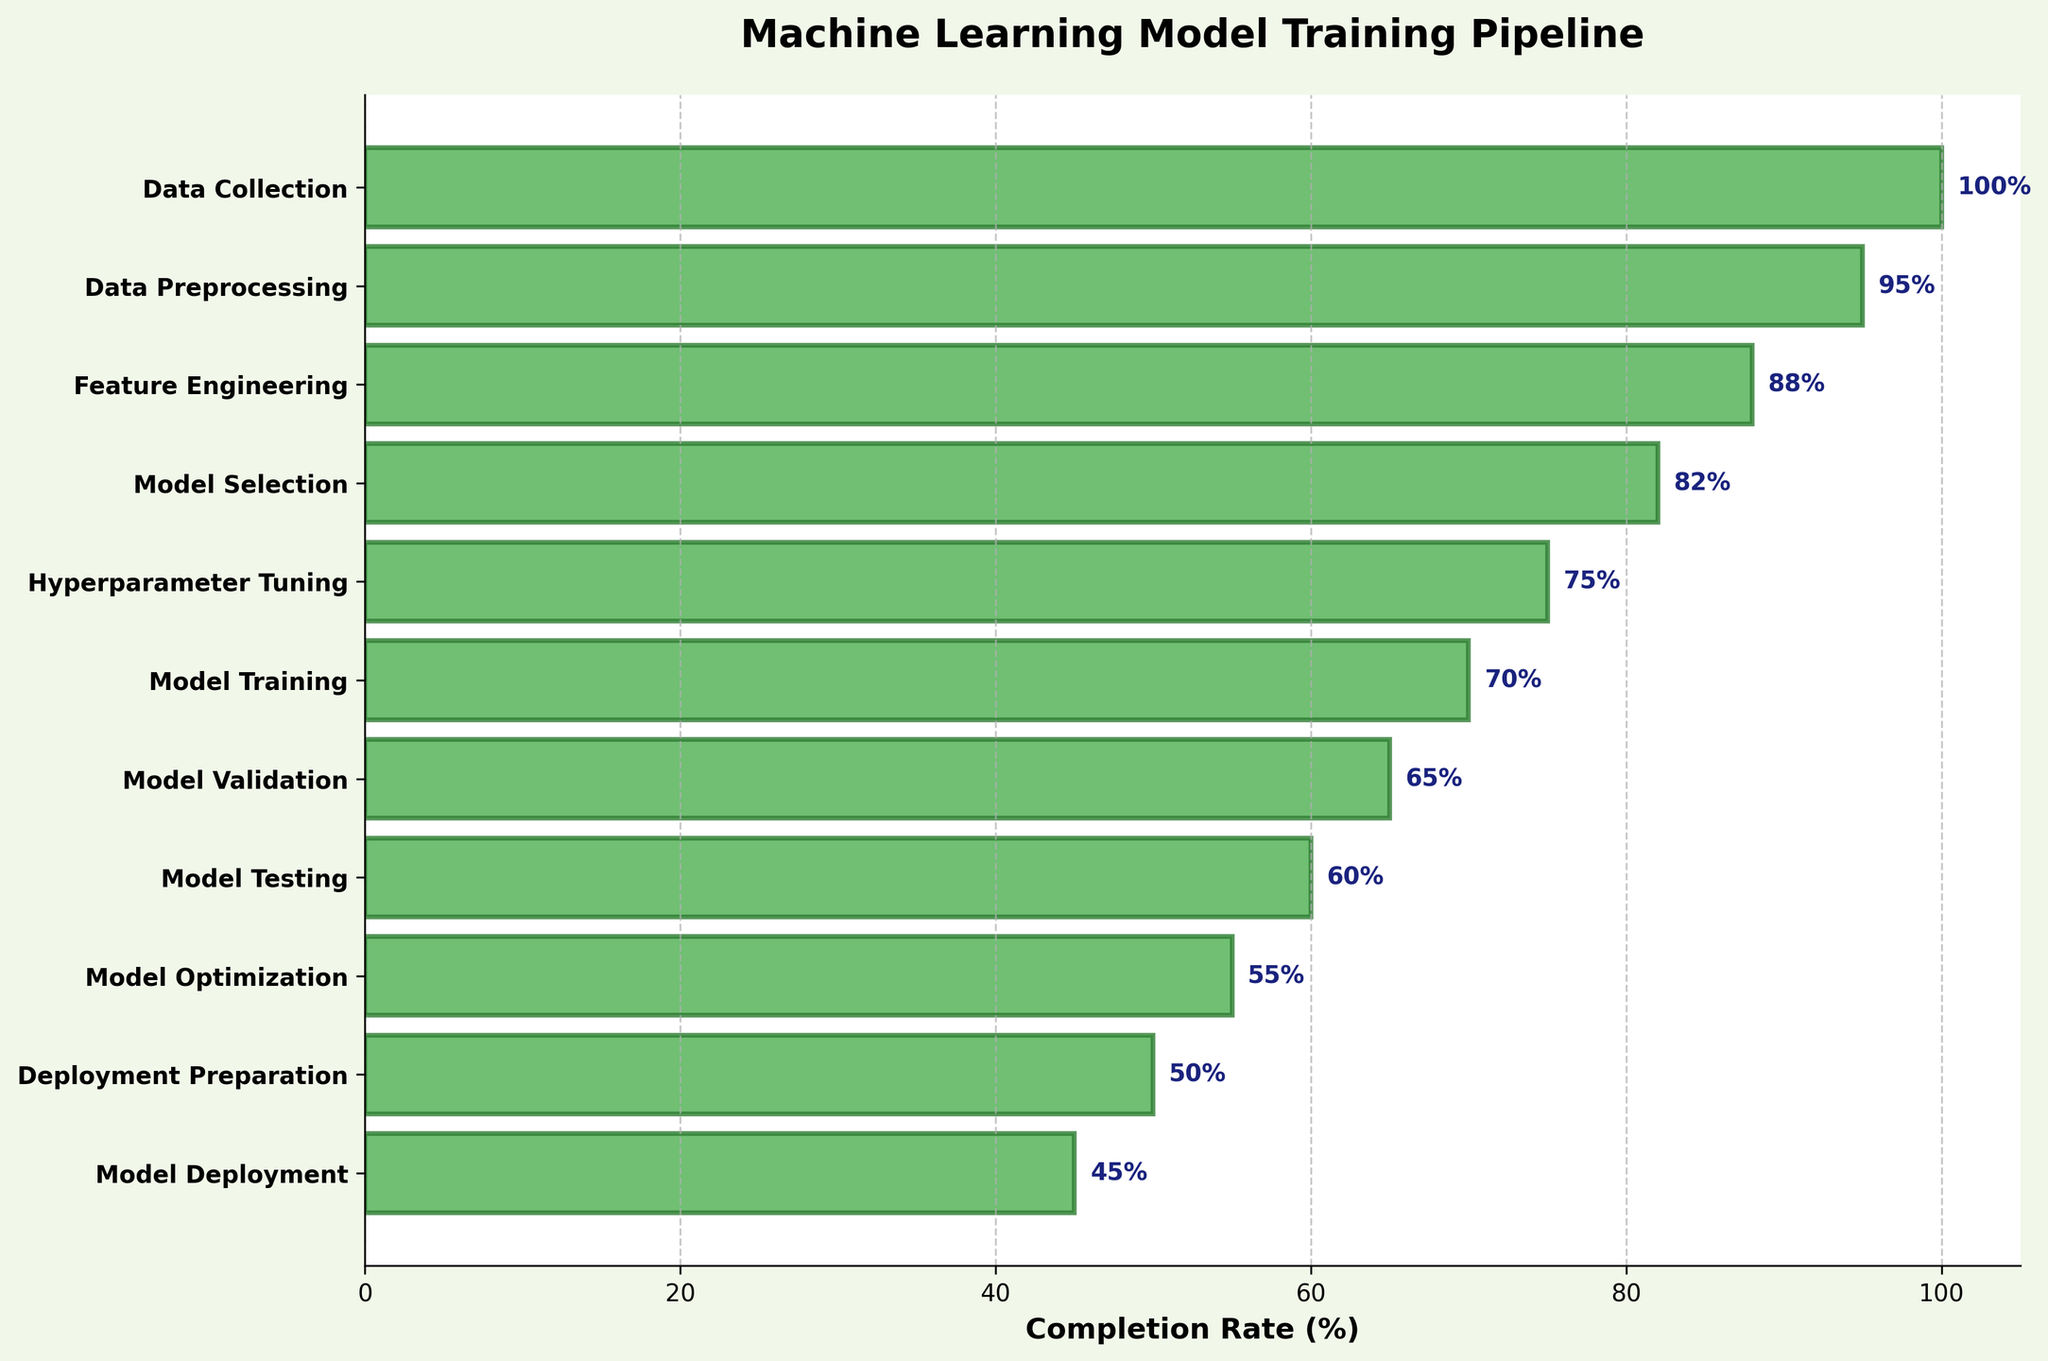What is the title of the chart? The title is located at the top and indicates the context of the chart.
Answer: Machine Learning Model Training Pipeline Which step has the highest completion rate? This can be identified by looking at the bar with the longest length or the farthest right label of the chart.
Answer: Data Collection What is the completion rate for Hyperparameter Tuning? Locate the "Hyperparameter Tuning" label along the vertical axis and read the corresponding value for its bar.
Answer: 75% What is the difference in completion rate between Model Training and Model Deployment? Find the rates for Model Training (70%) and Model Deployment (45%), then subtract the latter from the former: 70% - 45%.
Answer: 25% How does the completion rate for Data Preprocessing compare to Feature Engineering? Locate the completion rates for Data Preprocessing (95%) and Feature Engineering (88%), and compare them to see that Data Preprocessing is higher by 7%.
Answer: Data Preprocessing is higher by 7% Which step shows a 55% completion rate? Locate the bar with the value closest to 55% and identify the corresponding step label.
Answer: Model Optimization What are the first three steps in the pipeline? Read the labels of the first three steps starting from the top of the chart.
Answer: Data Collection, Data Preprocessing, Feature Engineering What is the average completion rate of all steps? Sum the completion rates (100 + 95 + 88 + 82 + 75 + 70 + 65 + 60 + 55 + 50 + 45 = 785) and divide by the number of steps (11). 785 / 11.
Answer: About 71.4% By how much does Deployment Preparation completion rate fall short of Data Collection? Calculate the difference between Data Collection (100%) and Deployment Preparation (50%): 100% - 50%.
Answer: 50% Which step shows the lowest completion rate, and by what percent does it trail behind the highest completion rate? Identify the lowest rate (Model Deployment, 45%) and compare it with the highest rate (Data Collection, 100%), then find the difference: 100% - 45%.
Answer: Model Deployment, 55% 